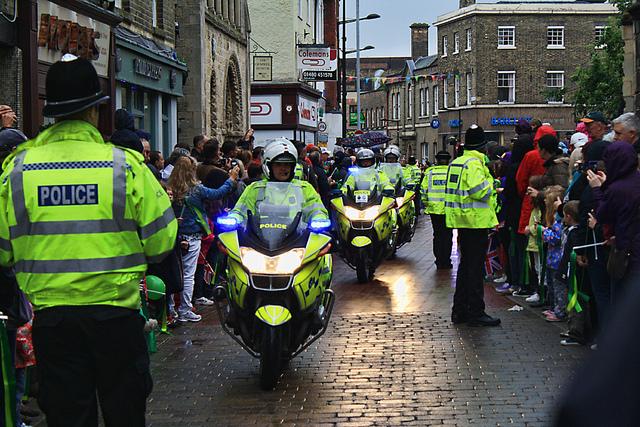Are the police causing a riot?
Quick response, please. No. How many police are on horses?
Quick response, please. 0. What are the police riding on?
Keep it brief. Motorcycles. Are the police riding motorcycles?
Keep it brief. Yes. 